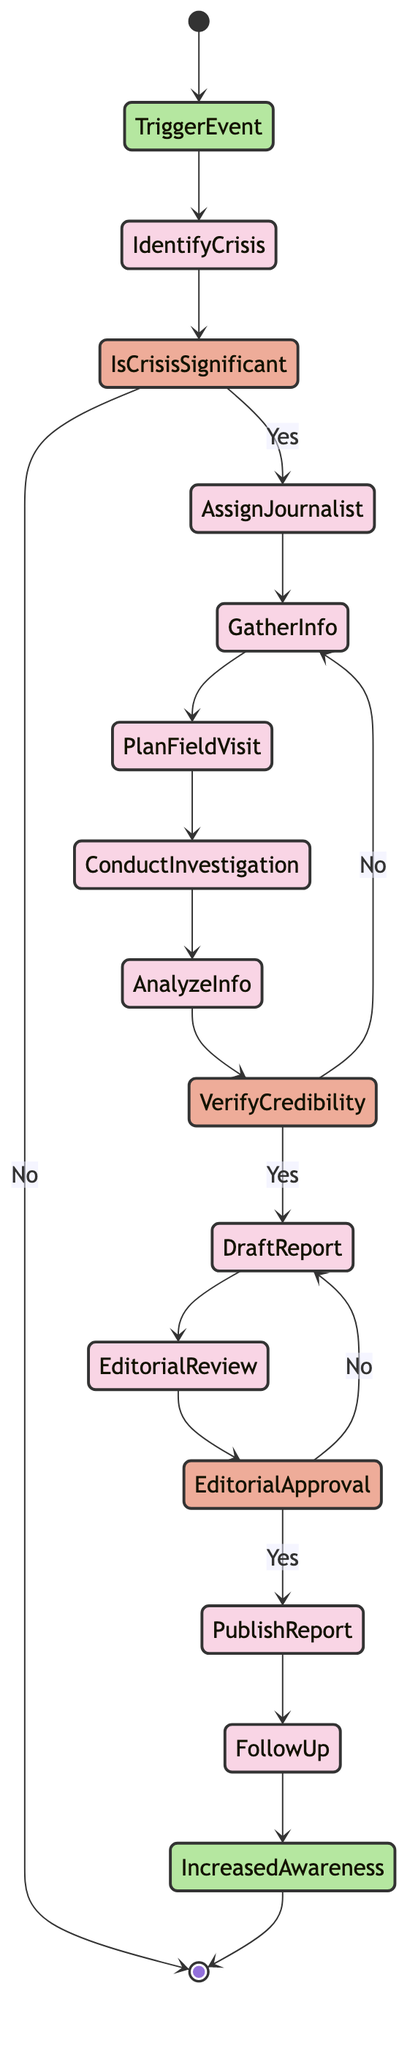What is the first activity in the diagram? The diagram starts with the node labeled "Trigger Event," which signifies the initial action that brings attention to the potential humanitarian crisis.
Answer: Trigger Event How many decision points are in the diagram? There are three decision points in the diagram: "Is Crisis Significant?", "Verify Credibility?", and "Editorial Approval?"
Answer: 3 What activity follows after "Analyze Collected Information"? After "Analyze Collected Information," the next step is the decision point labeled "Verify Credibility?" which evaluates the gathered information.
Answer: Verify Credibility What happens if the crisis is not significant? If the crisis is determined to not be significant at the decision point, the process ends, and there are no further activities or reports generated.
Answer: [*] How is the report published after the editorial review? If the draft report meets editorial standards, the process flows to the activity labeled "Publish Report," where the final report is released through various media channels.
Answer: Publish Report What is the end goal of the reporting process? The end event of the reporting process is labeled "Increased Awareness," which reflects the aim of raising public awareness about the humanitarian crisis.
Answer: Increased Awareness What activity is conducted before "Draft Report"? The activity that takes place before "Draft Report" is "Analyze Collected Information," which involves reviewing and verifying the accuracy of the gathered data.
Answer: Analyze Collected Information What is evaluated at the decision point "Verify Credibility?" At the "Verify Credibility?" decision point, the credibility and trustworthiness of the gathered information sources are evaluated.
Answer: Credibility What activity comes after "Conduct On-site Investigation"? After "Conduct On-site Investigation," the process moves to the activity named "Analyze Collected Information," where the journalist reviews the gathered evidence.
Answer: Analyze Collected Information How does the diagram indicate ongoing engagement after publishing the report? The diagram shows "Post-publication Follow-up" as the step that engages the audience through articles, Q&A sessions, and feedback collection post-publication.
Answer: Post-publication Follow-up 